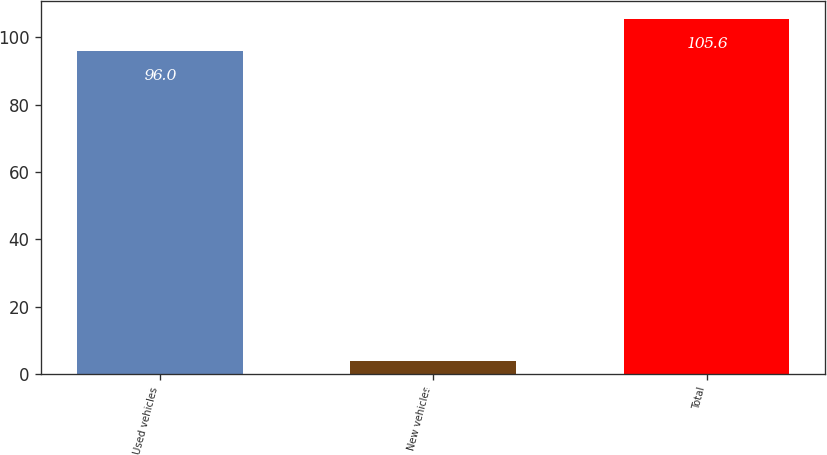<chart> <loc_0><loc_0><loc_500><loc_500><bar_chart><fcel>Used vehicles<fcel>New vehicles<fcel>Total<nl><fcel>96<fcel>4<fcel>105.6<nl></chart> 